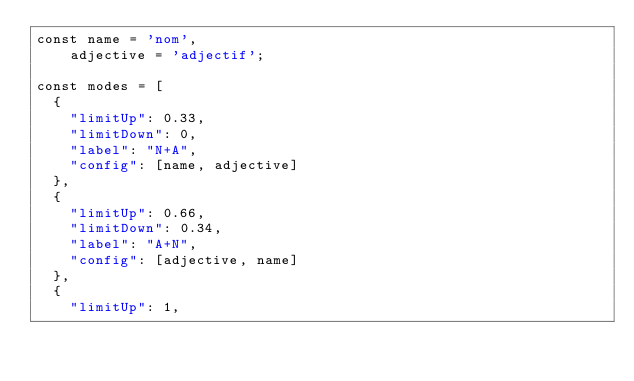<code> <loc_0><loc_0><loc_500><loc_500><_JavaScript_>const name = 'nom',
    adjective = 'adjectif';

const modes = [
  {
    "limitUp": 0.33,
    "limitDown": 0,
    "label": "N+A",
    "config": [name, adjective]
  },
  {
    "limitUp": 0.66,
    "limitDown": 0.34,
    "label": "A+N",
    "config": [adjective, name]
  },
  {
    "limitUp": 1,</code> 